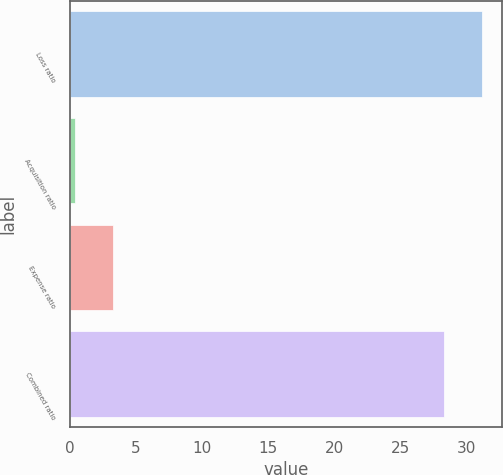Convert chart. <chart><loc_0><loc_0><loc_500><loc_500><bar_chart><fcel>Loss ratio<fcel>Acquisition ratio<fcel>Expense ratio<fcel>Combined ratio<nl><fcel>31.13<fcel>0.4<fcel>3.23<fcel>28.3<nl></chart> 